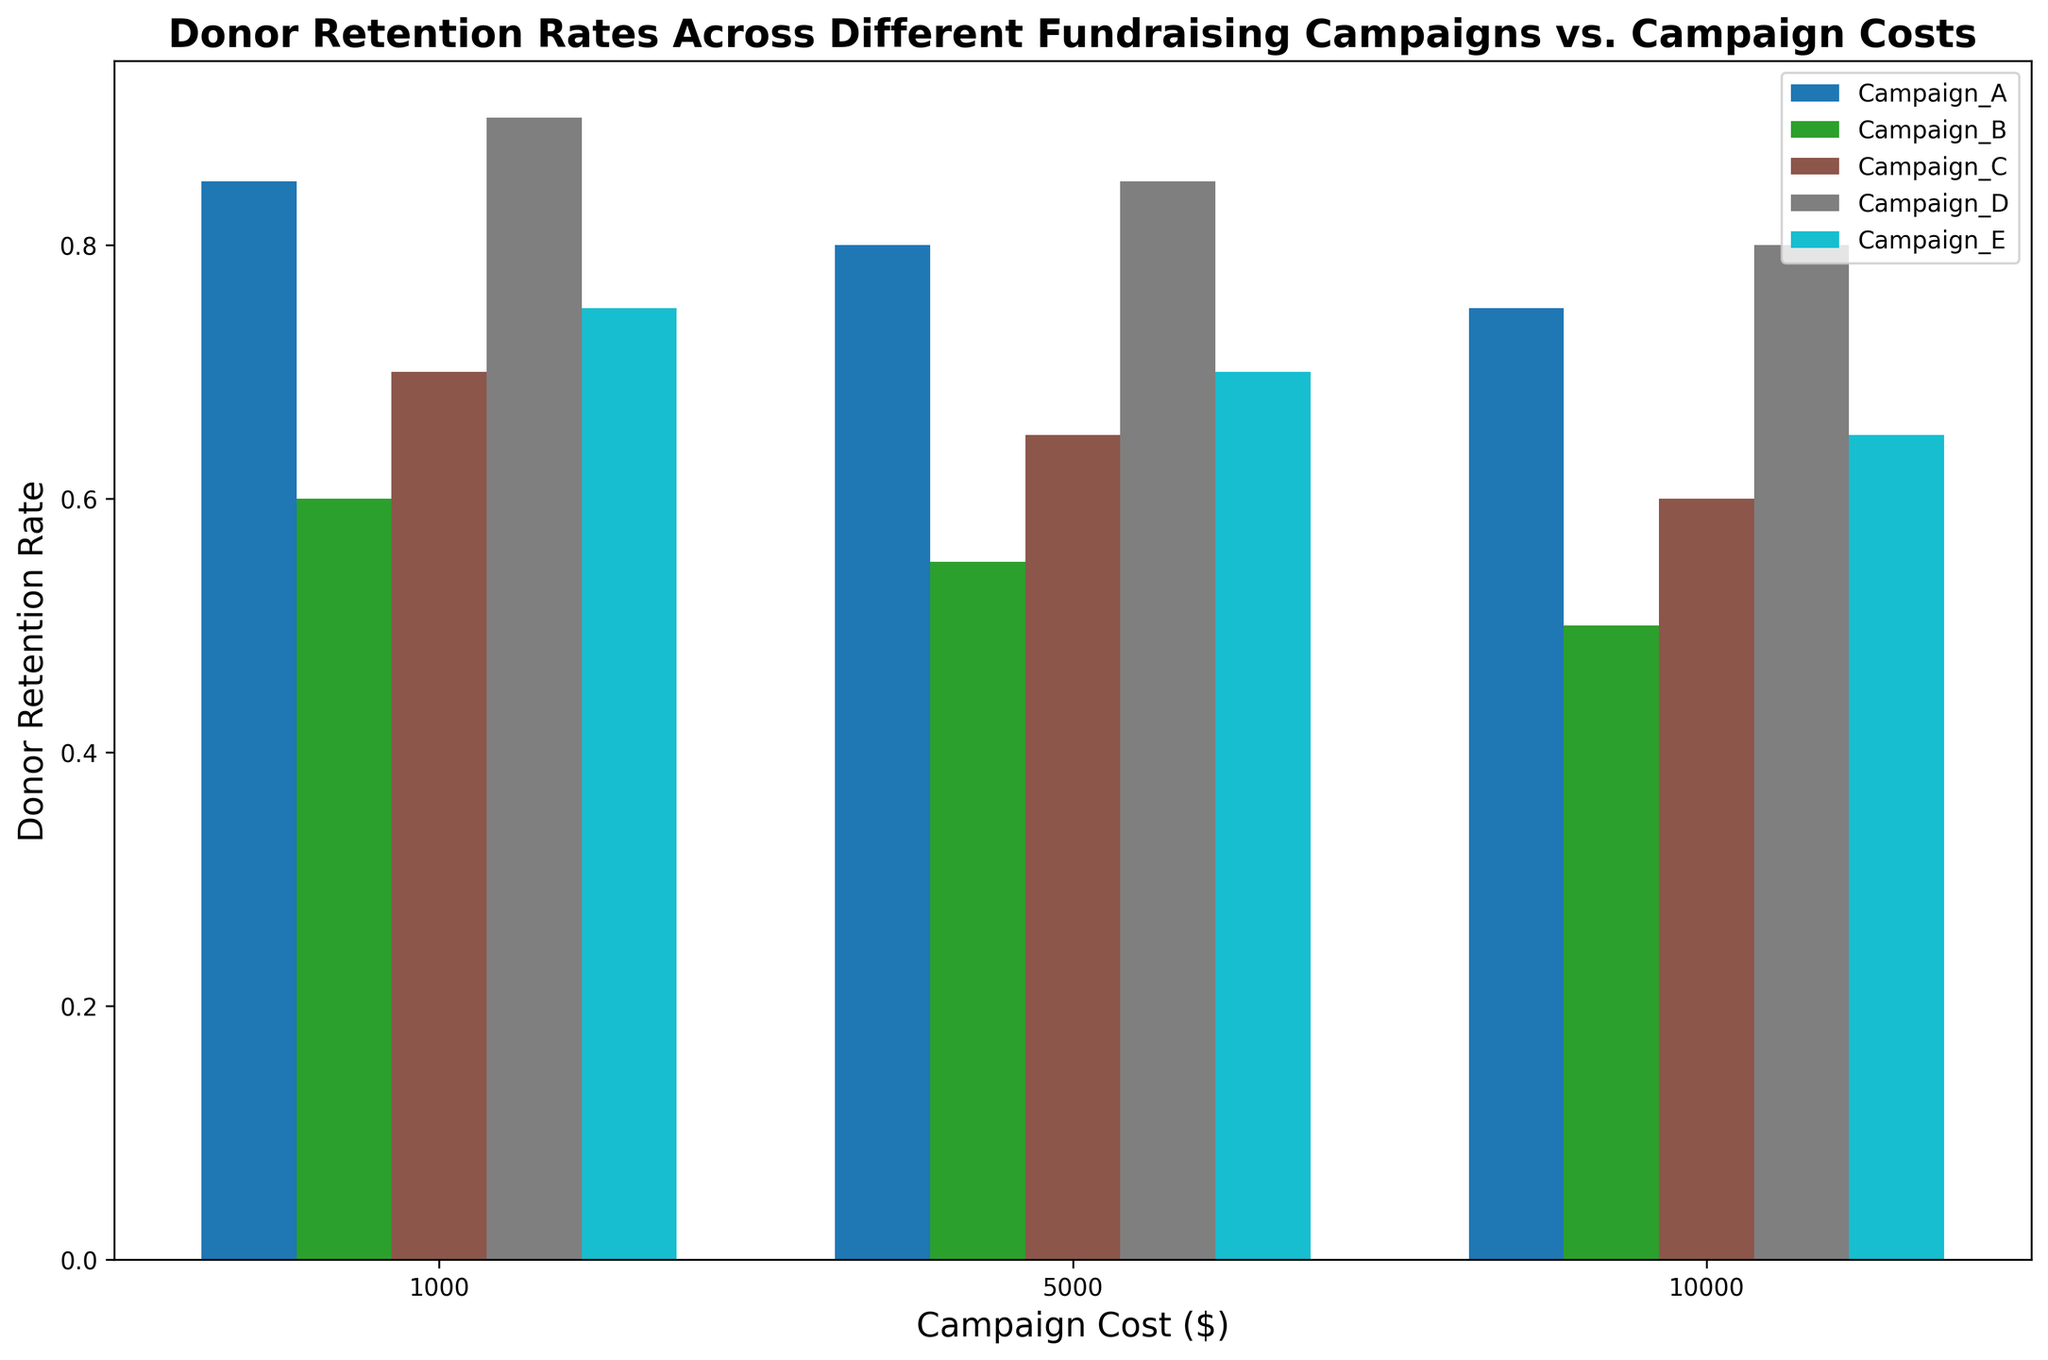What is the donor retention rate for Campaign A when the campaign cost is $5,000? Look at the bar for Campaign A with the cost label of $5,000 on the x-axis and identify the corresponding bar height representing the donor retention rate. In this case, it shows 0.80.
Answer: 0.80 Which campaign has the highest donor retention rate at the lowest campaign cost ($1,000)? All campaign bars at the $1,000 x-axis mark should be scanned. The bar for Campaign D is the tallest, indicating the highest donor retention rate at 0.90.
Answer: Campaign D How does the donor retention rate decrease for Campaign B as the campaign cost increases from $1,000 to $10,000? Identify the height of each bar for Campaign B at different costs. At $1,000 the rate is 0.60, at $5,000 it's 0.55, and at $10,000 it's 0.50. Calculate the differences: 0.60 - 0.55 = 0.05 and 0.55 - 0.50 = 0.05.
Answer: It decreases by 0.05 between each interval What is the average donor retention rate for Campaign E across all campaign costs? Add the donor retention rates for Campaign E at all campaign costs and then divide by the number of costs. (0.75 + 0.70 + 0.65) / 3 = 2.10 / 3 = 0.70.
Answer: 0.70 Which campaign exhibits the smallest decline in donor retention rate as the campaign cost increases from $1,000 to $10,000? Calculate the overall decrease in donor retention rates for each campaign from the lowest to the highest cost: Campaign A: 0.85 - 0.75 = 0.10, Campaign B: 0.60 - 0.50 = 0.10, Campaign C: 0.70 - 0.60 = 0.10, Campaign D: 0.90 - 0.80 = 0.10, Campaign E: 0.75 - 0.65 = 0.10. All campaigns have the same decline.
Answer: All Campaigns At a campaign cost of $5,000, which campaign has the highest donor retention rate and how does it compare to the campaign with the lowest rate at this cost? Identify the bars for all campaigns at the $5,000 x-axis mark. The highest is Campaign D at 0.85, the lowest is Campaign B at 0.55. The difference is 0.85 - 0.55 = 0.30.
Answer: Campaign D has the highest rate, 0.30 higher than the lowest (Campaign B) Which campaign has the highest average donor retention rate across all costs? Calculate the average donor retention rate for each campaign:
Campaign A: (0.85 + 0.80 + 0.75) / 3 = 0.80 
Campaign B: (0.60 + 0.55 + 0.50) / 3 = 0.55 
Campaign C: (0.70 + 0.65 + 0.60) / 3 = 0.65 
Campaign D: (0.90 + 0.85 + 0.80) / 3 = 0.85 
Campaign E: (0.75 + 0.70 + 0.65) / 3 = 0.70. The highest is 0.85 for Campaign D.
Answer: Campaign D Is there a campaign whose donor retention rate increases with higher campaign costs? Check each campaign's bars for a trend where the retention rate increases as the campaign cost increases. All campaigns show a decrease in retention rate as campaign cost increases.
Answer: No What is the difference in donor retention rates between Campaign A and Campaign C at a campaign cost of $10,000? Find the donor retention rate for Campaign A at $10,000, which is 0.75, and for Campaign C at $10,000, which is 0.60. Calculate the difference: 0.75 - 0.60 = 0.15.
Answer: 0.15 